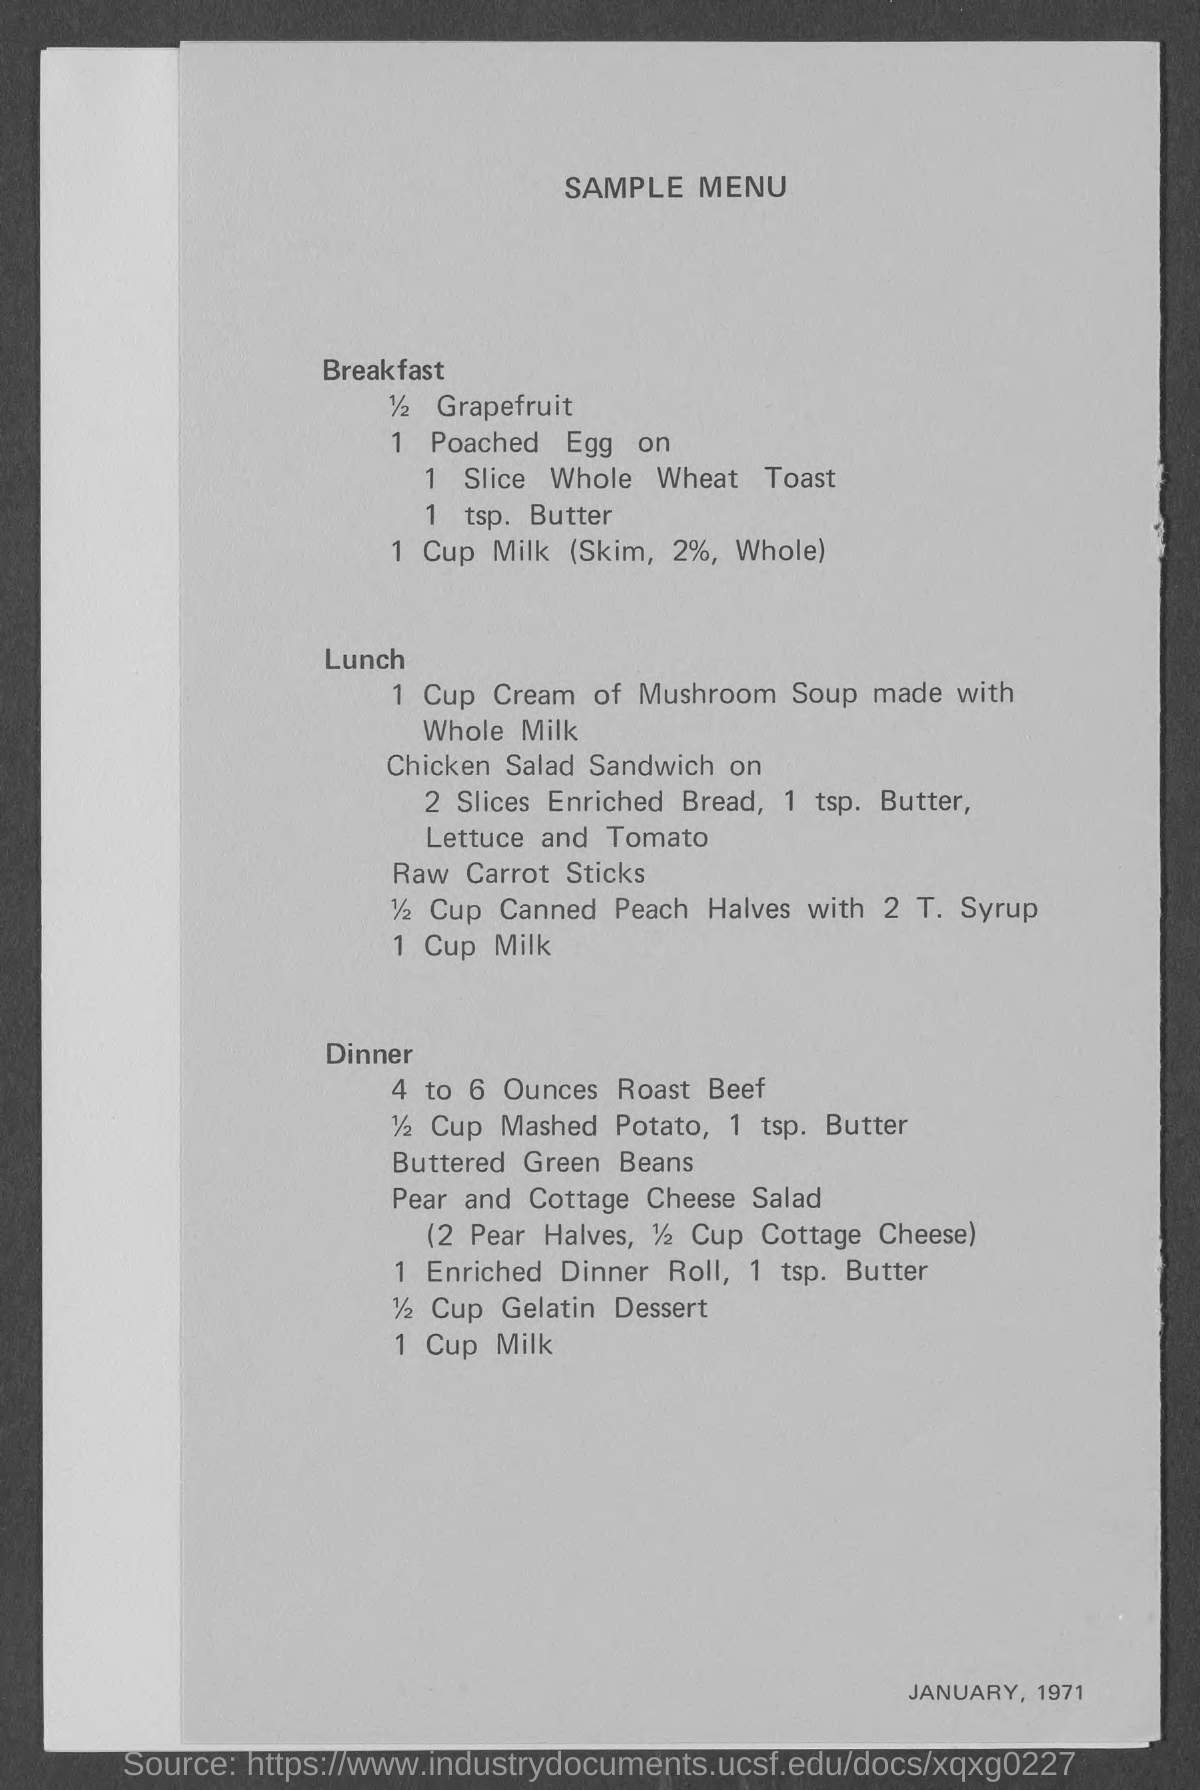Draw attention to some important aspects in this diagram. The title of the document is SAMPLE MENU.. I would like to order one serving of whole wheat toast, please. 